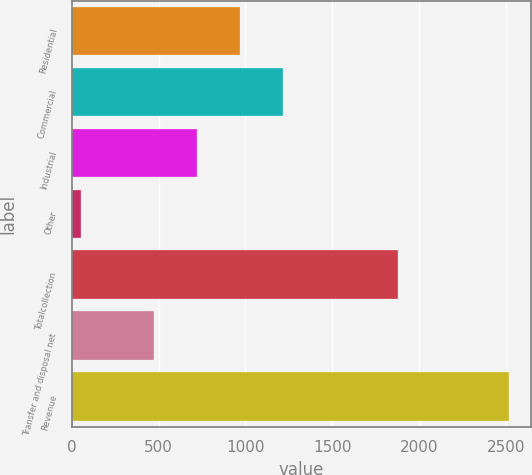Convert chart to OTSL. <chart><loc_0><loc_0><loc_500><loc_500><bar_chart><fcel>Residential<fcel>Commercial<fcel>Industrial<fcel>Other<fcel>Totalcollection<fcel>Transfer and disposal net<fcel>Revenue<nl><fcel>967.18<fcel>1213.87<fcel>720.49<fcel>50.9<fcel>1881.1<fcel>473.8<fcel>2517.8<nl></chart> 